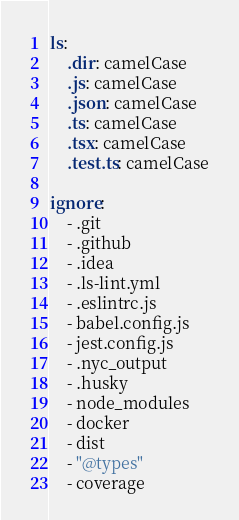<code> <loc_0><loc_0><loc_500><loc_500><_YAML_>ls:
    .dir: camelCase
    .js: camelCase
    .json: camelCase
    .ts: camelCase
    .tsx: camelCase
    .test.ts: camelCase
    
ignore:
    - .git
    - .github
    - .idea
    - .ls-lint.yml
    - .eslintrc.js
    - babel.config.js
    - jest.config.js
    - .nyc_output
    - .husky
    - node_modules
    - docker
    - dist
    - "@types"
    - coverage
</code> 